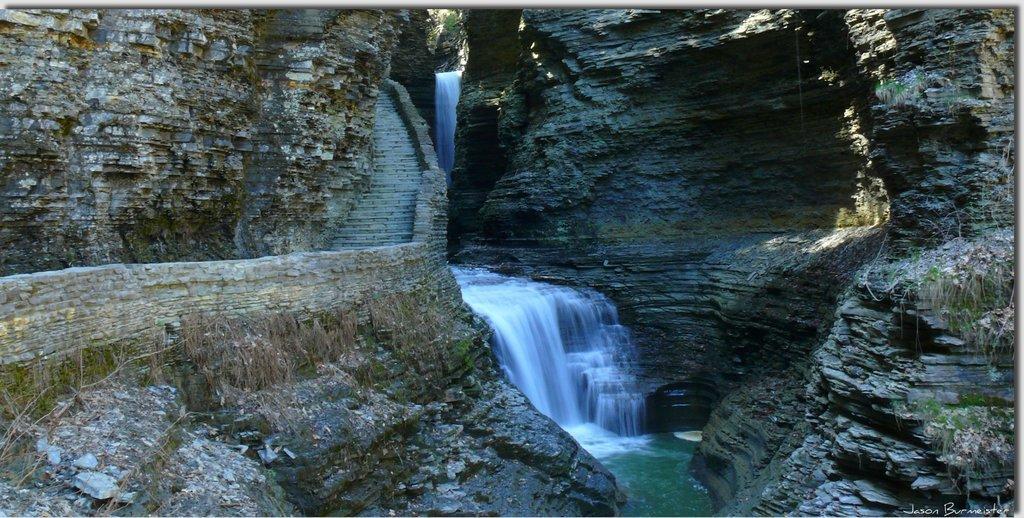How would you summarize this image in a sentence or two? In the middle water is falling from the rocks and on the left and right side we can see rock mountain. 